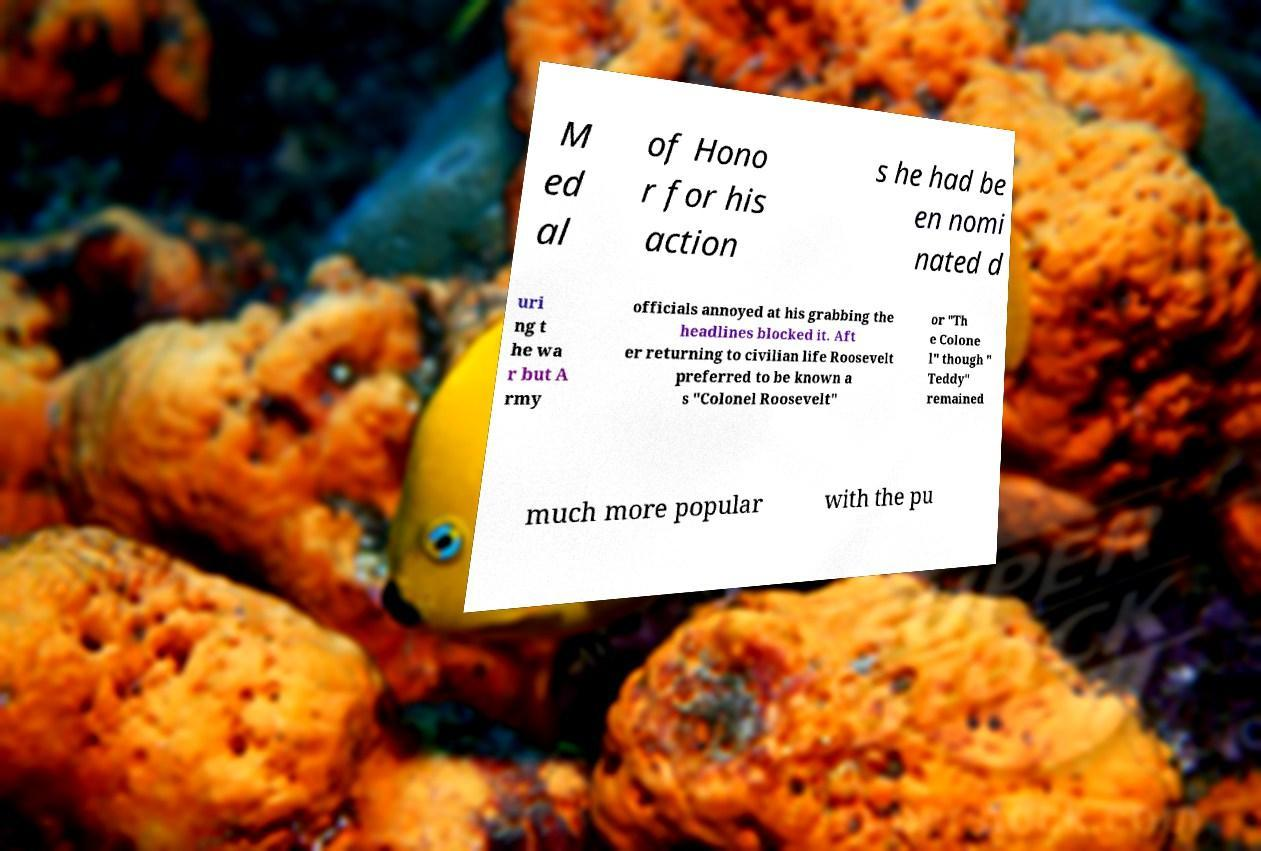I need the written content from this picture converted into text. Can you do that? M ed al of Hono r for his action s he had be en nomi nated d uri ng t he wa r but A rmy officials annoyed at his grabbing the headlines blocked it. Aft er returning to civilian life Roosevelt preferred to be known a s "Colonel Roosevelt" or "Th e Colone l" though " Teddy" remained much more popular with the pu 